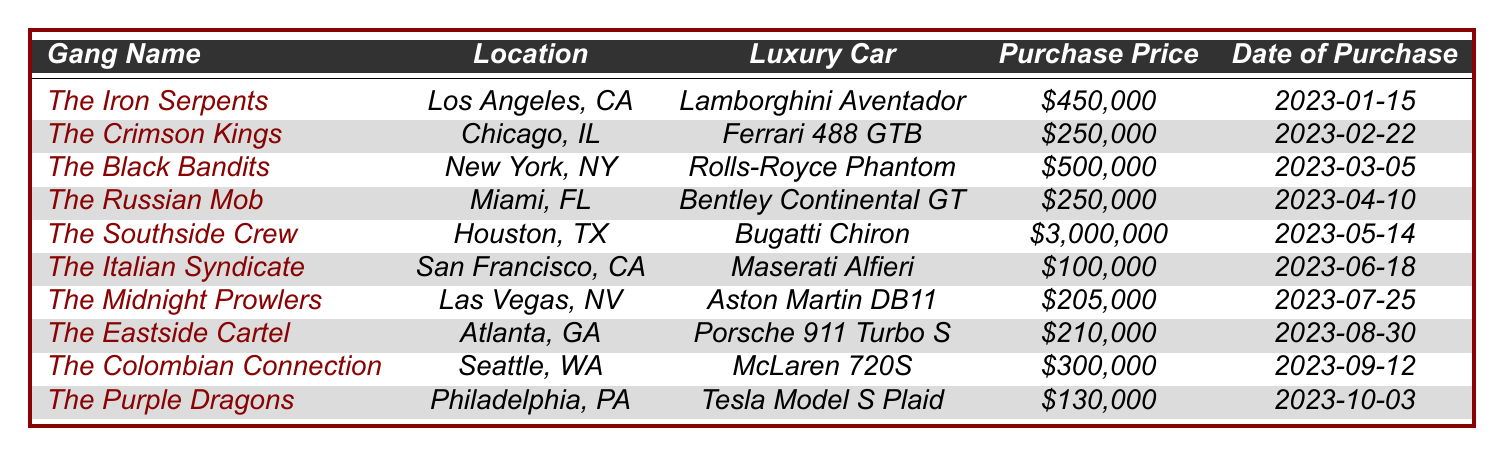What luxury car did The Southside Crew purchase? The Southside Crew is listed in the table, and their luxury car is mentioned alongside their gang name. Therefore, referring to the table, I can directly see that they purchased a Bugatti Chiron.
Answer: Bugatti Chiron What was the purchase price of the Rolls-Royce Phantom? By looking at the entry for The Black Bandits in the table, I notice that under the column for Purchase Price, it states $500,000 for the Rolls-Royce Phantom.
Answer: $500,000 Which gang made the highest car purchase in 2023? The Southside Crew is highlighted in the table for having a purchase price of $3,000,000 for their Bugatti Chiron, which is the highest among all listed.
Answer: The Southside Crew How many gangs purchased cars for more than $200,000? To answer this, I will count all entries in the Purchase Price column that exceed $200,000. The gangs that meet this criterion are The Iron Serpents, The Black Bandits, The Southside Crew, The Colombian Connection, and The Crimson Kings. This gives us a total count of 5 gangs.
Answer: 5 What is the total amount spent by The Iron Serpents and The Black Bandits on their luxury cars? First, I identify the purchase prices for both gangs. The Iron Serpents spent $450,000, and The Black Bandits spent $500,000. Adding these amounts together results in $450,000 + $500,000 = $950,000.
Answer: $950,000 Is the purchase price of the luxury car bought by The Italian Syndicate greater than $150,000? Referencing the table, I see that The Italian Syndicate purchased their Maserati Alfieri for $100,000, which is indeed less than $150,000. Therefore, the answer is no.
Answer: No What is the average purchase price of the luxury cars listed in the table? To find the average, I first sum the purchase prices: $450,000 + $250,000 + $500,000 + $250,000 + $3,000,000 + $100,000 + $205,000 + $210,000 + $300,000 + $130,000 = $5,095,000. There are 10 entries, so I divide $5,095,000 by 10, resulting in an average of $509,500.
Answer: $509,500 Which gang purchased a luxury car in Philadelphia? Looking at the table, I find The Purple Dragons listed under the location column where it specifies that they are based in Philadelphia, PA, implying they purchased their luxury car there.
Answer: The Purple Dragons Was the Bentley Continental GT bought before the Bugatti Chiron? By checking the table, I note that the Bentley Continental GT was purchased on 2023-04-10 and the Bugatti Chiron on 2023-05-14. Since April precedes May, the statement is true.
Answer: Yes How many luxury cars were purchased between March and August 2023? I need to count the entries with purchase dates from March 1 to August 31, 2023. The cars purchased in this period are the Rolls-Royce Phantom, Bentley Continental GT, Bugatti Chiron, Maserati Alfieri, Aston Martin DB11, and Porsche 911 Turbo S, which total 6 cars.
Answer: 6 Who spent the least amount on a luxury car, and what was the amount? The Italian Syndicate purchased their Maserati Alfieri for $100,000, which is the lowest amount listed in the table as every other gang spent more than this amount.
Answer: The Italian Syndicate, $100,000 